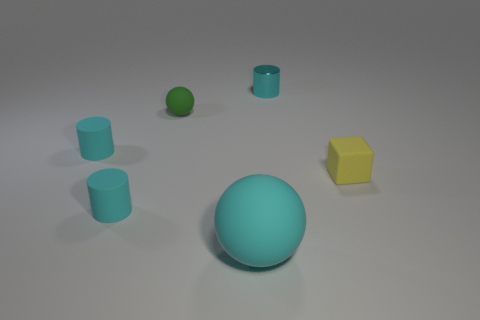What number of other things are the same color as the tiny metallic cylinder?
Give a very brief answer. 3. What material is the green sphere that is the same size as the yellow block?
Provide a short and direct response. Rubber. Is there a cyan metal thing of the same size as the green rubber object?
Ensure brevity in your answer.  Yes. There is a sphere in front of the yellow thing; what is its material?
Your response must be concise. Rubber. Is the tiny object that is in front of the small yellow thing made of the same material as the yellow thing?
Provide a short and direct response. Yes. There is a yellow rubber object that is the same size as the green thing; what shape is it?
Keep it short and to the point. Cube. What number of small cylinders have the same color as the big sphere?
Your answer should be very brief. 3. Are there fewer big matte balls that are behind the cyan rubber sphere than yellow rubber cubes that are behind the yellow rubber object?
Your answer should be compact. No. There is a small yellow thing; are there any small cyan rubber objects in front of it?
Offer a terse response. Yes. Are there any matte cylinders left of the cyan thing in front of the matte cylinder in front of the block?
Your answer should be compact. Yes. 